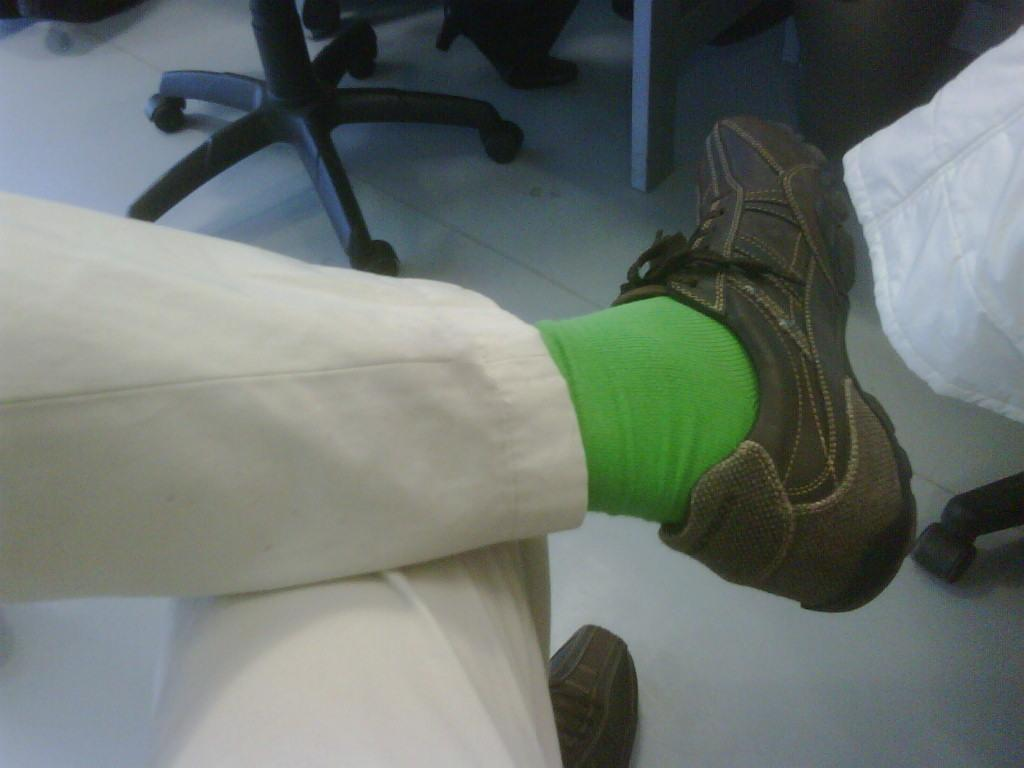What can be seen at the bottom of the image? There are legs with shoes visible in the image. What type of furniture can be seen in the background of the image? There are two chairs in the background of the image. What type of nut is being cracked by the person in the image? There is no person or nut present in the image; it only shows legs with shoes and chairs in the background. 